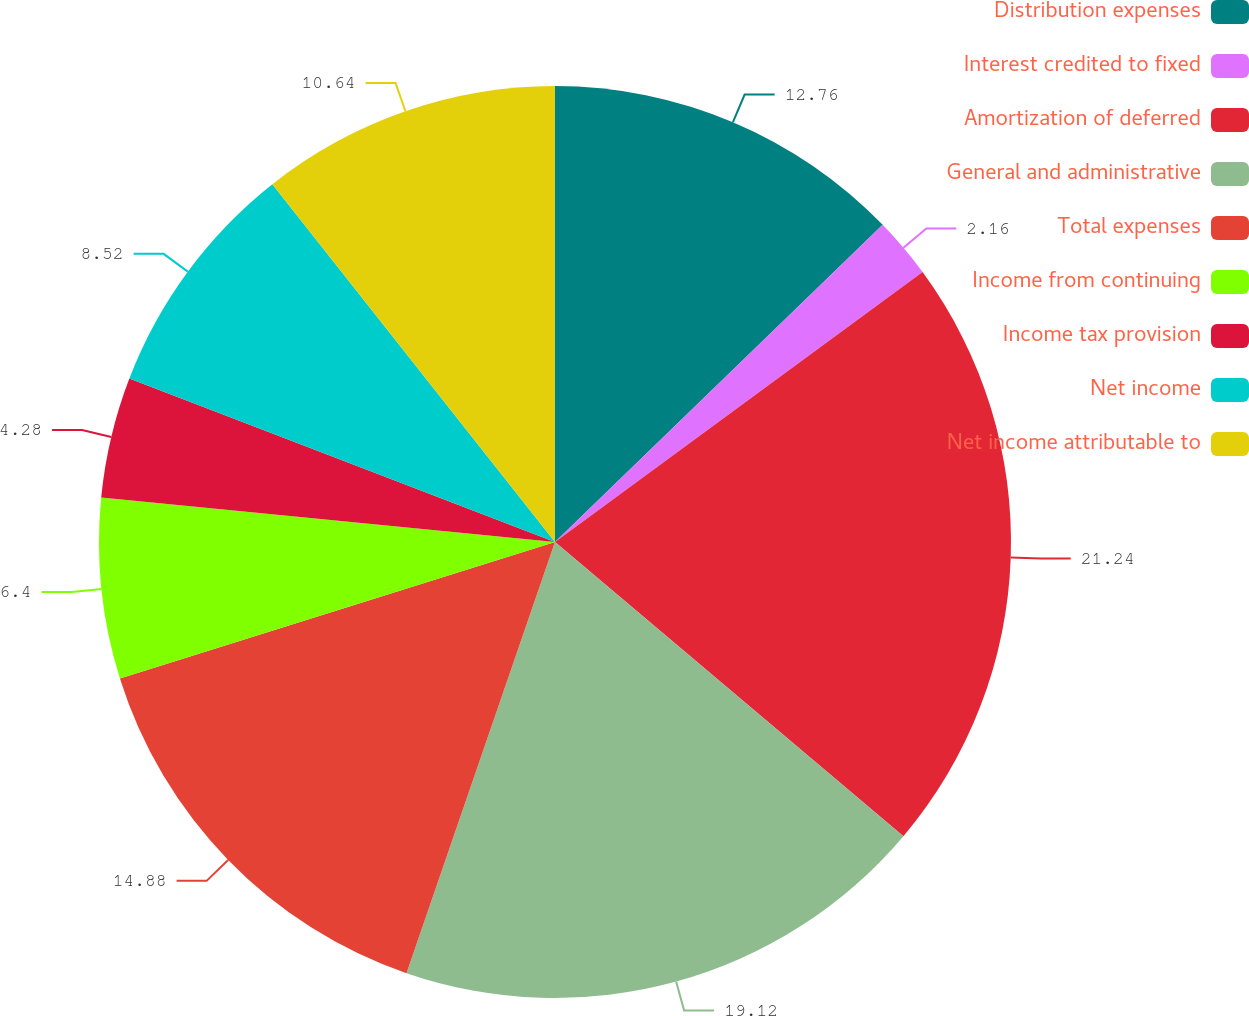Convert chart. <chart><loc_0><loc_0><loc_500><loc_500><pie_chart><fcel>Distribution expenses<fcel>Interest credited to fixed<fcel>Amortization of deferred<fcel>General and administrative<fcel>Total expenses<fcel>Income from continuing<fcel>Income tax provision<fcel>Net income<fcel>Net income attributable to<nl><fcel>12.76%<fcel>2.16%<fcel>21.24%<fcel>19.12%<fcel>14.88%<fcel>6.4%<fcel>4.28%<fcel>8.52%<fcel>10.64%<nl></chart> 